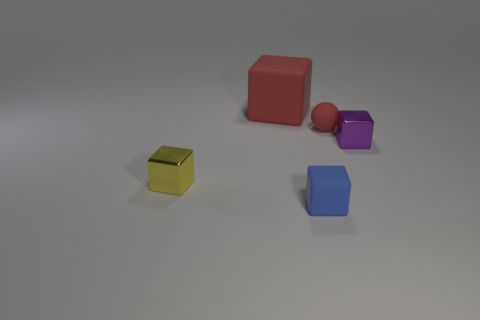What shape is the matte thing that is the same color as the large matte block?
Your answer should be compact. Sphere. Do the metallic object to the left of the rubber ball and the block behind the tiny purple thing have the same size?
Give a very brief answer. No. Are there any other things that are the same size as the red rubber block?
Your answer should be very brief. No. What is the color of the matte block in front of the tiny rubber object behind the tiny blue cube?
Provide a short and direct response. Blue. What is the shape of the tiny red matte object?
Ensure brevity in your answer.  Sphere. There is a matte thing that is both behind the blue rubber thing and right of the large red thing; what is its shape?
Offer a terse response. Sphere. The big object that is made of the same material as the ball is what color?
Offer a terse response. Red. The tiny metallic object that is on the left side of the metallic thing to the right of the rubber thing that is to the left of the blue thing is what shape?
Your answer should be compact. Cube. How big is the red matte cube?
Ensure brevity in your answer.  Large. What is the shape of the other small object that is made of the same material as the yellow thing?
Your response must be concise. Cube. 